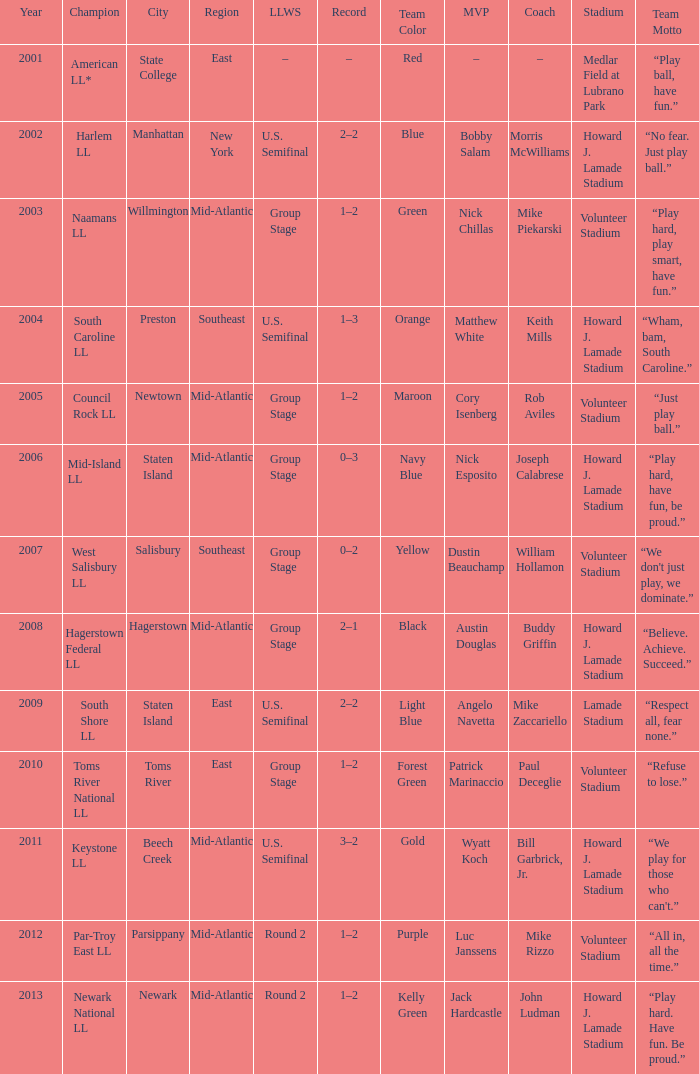Which edition of the little league world series was held in parsippany? Round 2. Help me parse the entirety of this table. {'header': ['Year', 'Champion', 'City', 'Region', 'LLWS', 'Record', 'Team Color', 'MVP', 'Coach', 'Stadium', 'Team Motto'], 'rows': [['2001', 'American LL*', 'State College', 'East', '–', '–', 'Red', '–', '–', 'Medlar Field at Lubrano Park', '“Play ball, have fun.”'], ['2002', 'Harlem LL', 'Manhattan', 'New York', 'U.S. Semifinal', '2–2', 'Blue', 'Bobby Salam', 'Morris McWilliams', 'Howard J. Lamade Stadium', '“No fear. Just play ball.”'], ['2003', 'Naamans LL', 'Willmington', 'Mid-Atlantic', 'Group Stage', '1–2', 'Green', 'Nick Chillas', 'Mike Piekarski', 'Volunteer Stadium', '“Play hard, play smart, have fun.”'], ['2004', 'South Caroline LL', 'Preston', 'Southeast', 'U.S. Semifinal', '1–3', 'Orange', 'Matthew White', 'Keith Mills', 'Howard J. Lamade Stadium', '“Wham, bam, South Caroline.”'], ['2005', 'Council Rock LL', 'Newtown', 'Mid-Atlantic', 'Group Stage', '1–2', 'Maroon', 'Cory Isenberg', 'Rob Aviles', 'Volunteer Stadium', '“Just play ball.”'], ['2006', 'Mid-Island LL', 'Staten Island', 'Mid-Atlantic', 'Group Stage', '0–3', 'Navy Blue', 'Nick Esposito', 'Joseph Calabrese', 'Howard J. Lamade Stadium', '“Play hard, have fun, be proud.”'], ['2007', 'West Salisbury LL', 'Salisbury', 'Southeast', 'Group Stage', '0–2', 'Yellow', 'Dustin Beauchamp', 'William Hollamon', 'Volunteer Stadium', "“We don't just play, we dominate.”"], ['2008', 'Hagerstown Federal LL', 'Hagerstown', 'Mid-Atlantic', 'Group Stage', '2–1', 'Black', 'Austin Douglas', 'Buddy Griffin', 'Howard J. Lamade Stadium', '“Believe. Achieve. Succeed.”'], ['2009', 'South Shore LL', 'Staten Island', 'East', 'U.S. Semifinal', '2–2', 'Light Blue', 'Angelo Navetta', 'Mike Zaccariello', 'Lamade Stadium', '“Respect all, fear none.”'], ['2010', 'Toms River National LL', 'Toms River', 'East', 'Group Stage', '1–2', 'Forest Green', 'Patrick Marinaccio', 'Paul Deceglie', 'Volunteer Stadium', '“Refuse to lose.”'], ['2011', 'Keystone LL', 'Beech Creek', 'Mid-Atlantic', 'U.S. Semifinal', '3–2', 'Gold', 'Wyatt Koch', 'Bill Garbrick, Jr.', 'Howard J. Lamade Stadium', "“We play for those who can't.”"], ['2012', 'Par-Troy East LL', 'Parsippany', 'Mid-Atlantic', 'Round 2', '1–2', 'Purple', 'Luc Janssens', 'Mike Rizzo', 'Volunteer Stadium', '“All in, all the time.”'], ['2013', 'Newark National LL', 'Newark', 'Mid-Atlantic', 'Round 2', '1–2', 'Kelly Green', 'Jack Hardcastle', 'John Ludman', 'Howard J. Lamade Stadium', '“Play hard. Have fun. Be proud.”']]} 